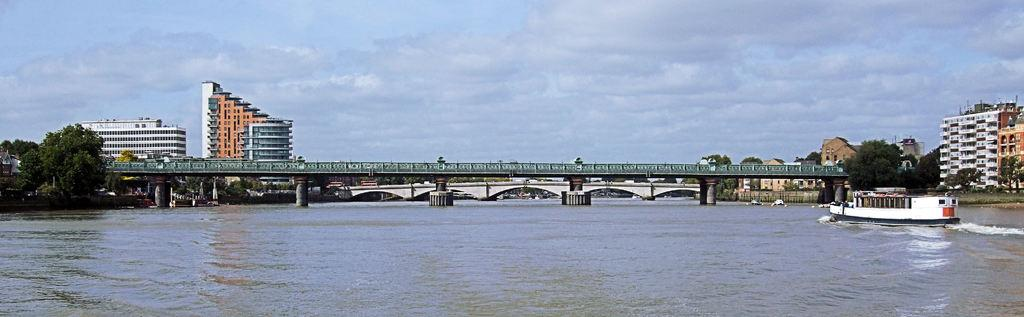What type of vehicles can be seen in the image? There are boats in the image. What structures are present in the image? There are bridges, buildings, and pillars in the image. What natural elements can be seen in the image? There is water and trees visible in the image. What is the condition of the sky in the image? The sky appears to be cloudy in the image. What else can be found in the image? There are objects in the image. Can you see any fog in the image? There is no mention of fog in the image; the sky appears to be cloudy. What type of card is being used to navigate the boats in the image? There is no card present in the image, and the boats are not shown to be navigating. 